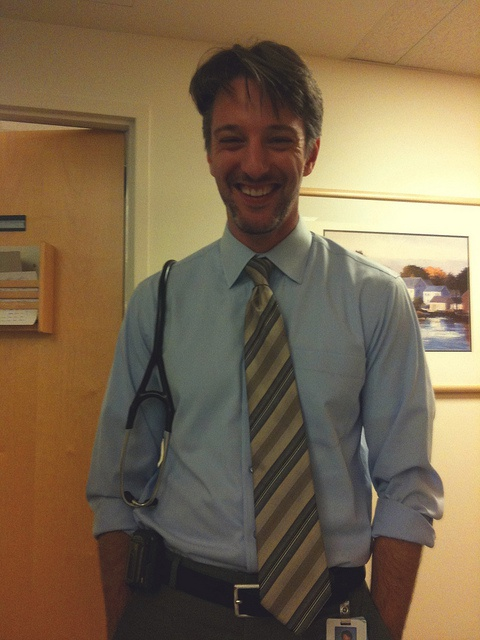Describe the objects in this image and their specific colors. I can see people in brown, gray, black, and maroon tones and tie in brown, black, and gray tones in this image. 